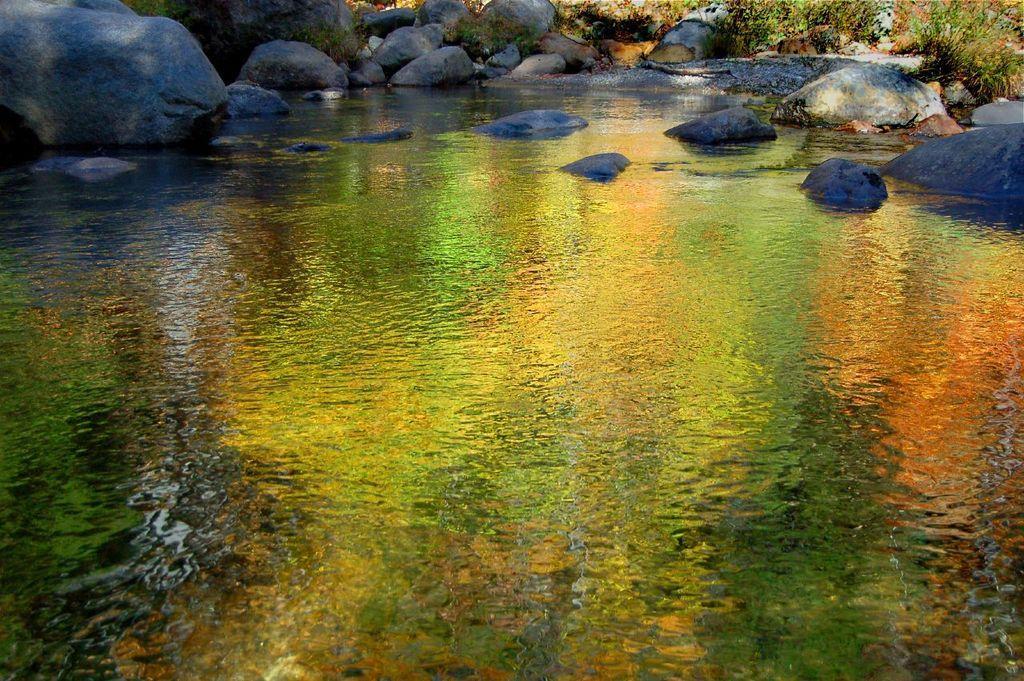Can you describe this image briefly? In the picture we can see the water surface, far away from it, we can see the rocks and the plants. 